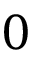Convert formula to latex. <formula><loc_0><loc_0><loc_500><loc_500>0</formula> 